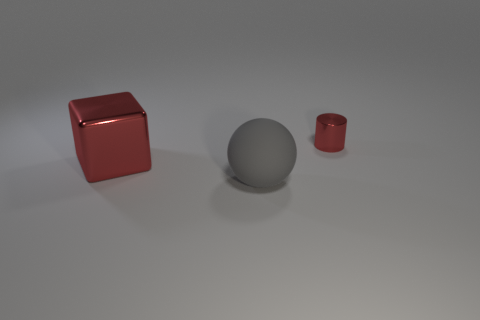Add 2 large metallic objects. How many objects exist? 5 Subtract all cylinders. How many objects are left? 2 Add 2 brown shiny spheres. How many brown shiny spheres exist? 2 Subtract 1 red blocks. How many objects are left? 2 Subtract all cubes. Subtract all cubes. How many objects are left? 1 Add 2 tiny metallic cylinders. How many tiny metallic cylinders are left? 3 